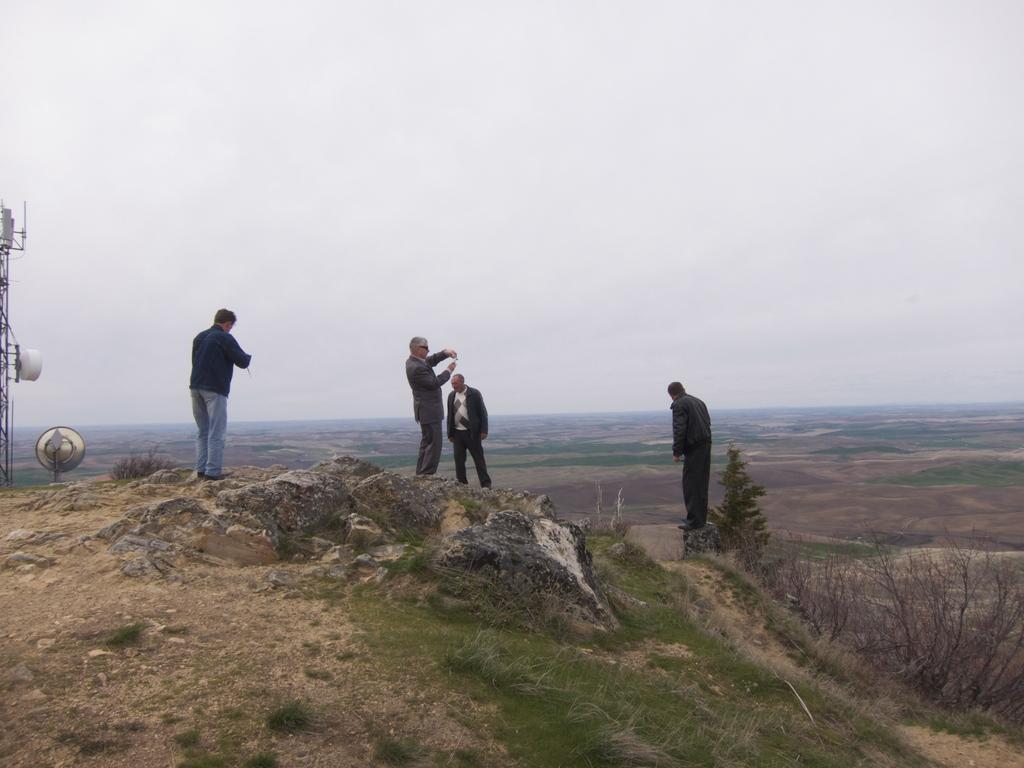Can you describe this image briefly? In the center of the image we can see people standing on the hill. On the right there is a bush. In the background there is sky. 